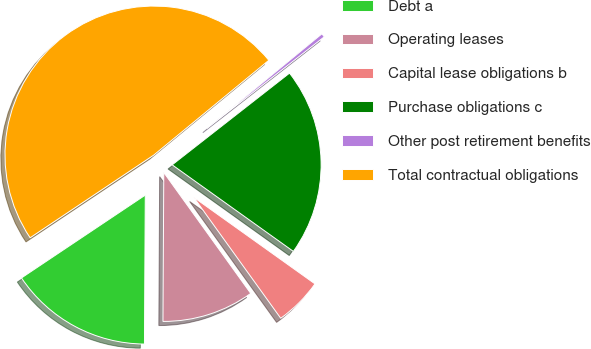Convert chart. <chart><loc_0><loc_0><loc_500><loc_500><pie_chart><fcel>Debt a<fcel>Operating leases<fcel>Capital lease obligations b<fcel>Purchase obligations c<fcel>Other post retirement benefits<fcel>Total contractual obligations<nl><fcel>15.53%<fcel>10.01%<fcel>5.21%<fcel>20.43%<fcel>0.41%<fcel>48.42%<nl></chart> 